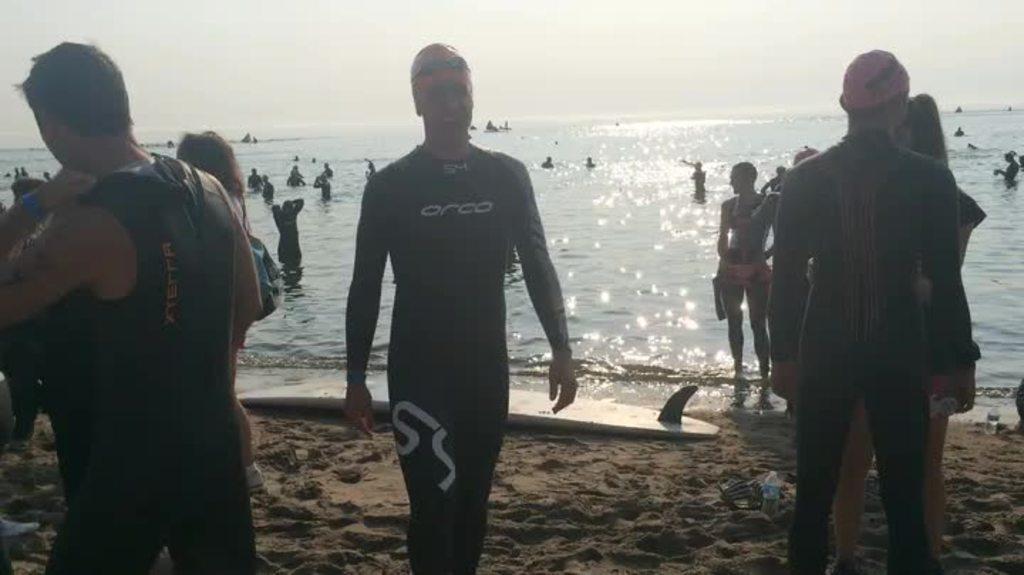Please provide a concise description of this image. There are some persons standing in the beach area as we can see at the bottom of this image. There is a Sea in the background and there is a sky at the top of this image. 